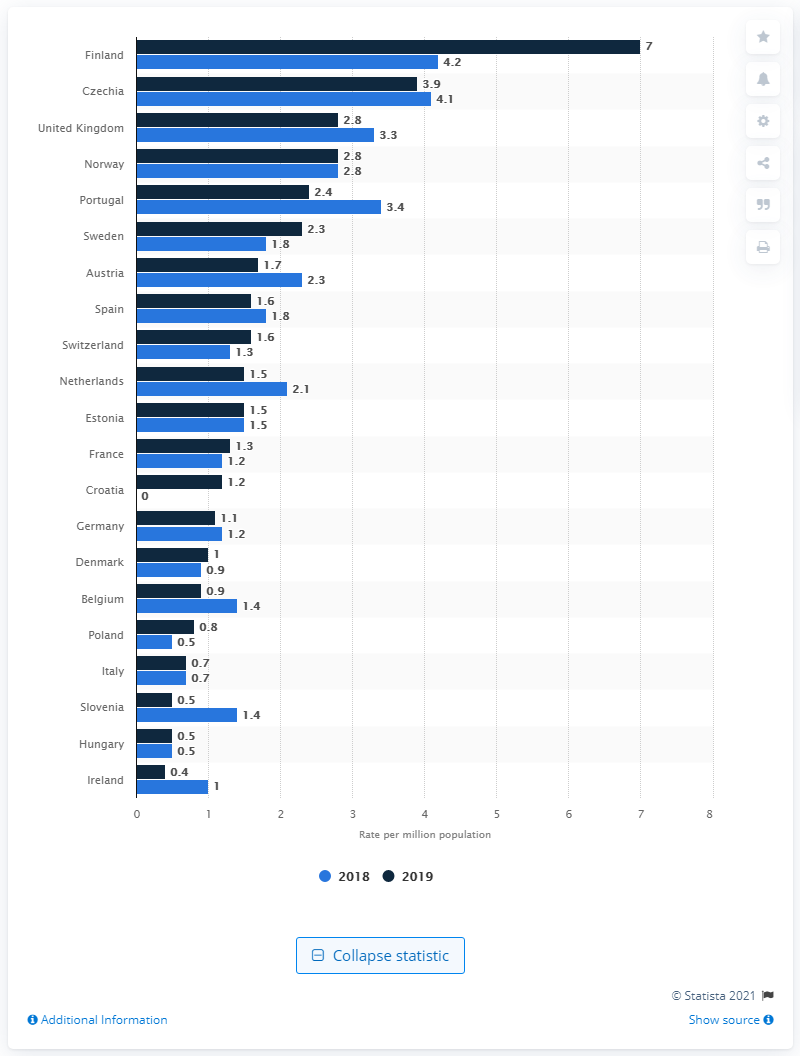List a handful of essential elements in this visual. In 2018, Finland reported a high rate of pancreas transplants with a value of 4.2. The second highest rate of pancreas transplants was observed in Czechia in 2019. 